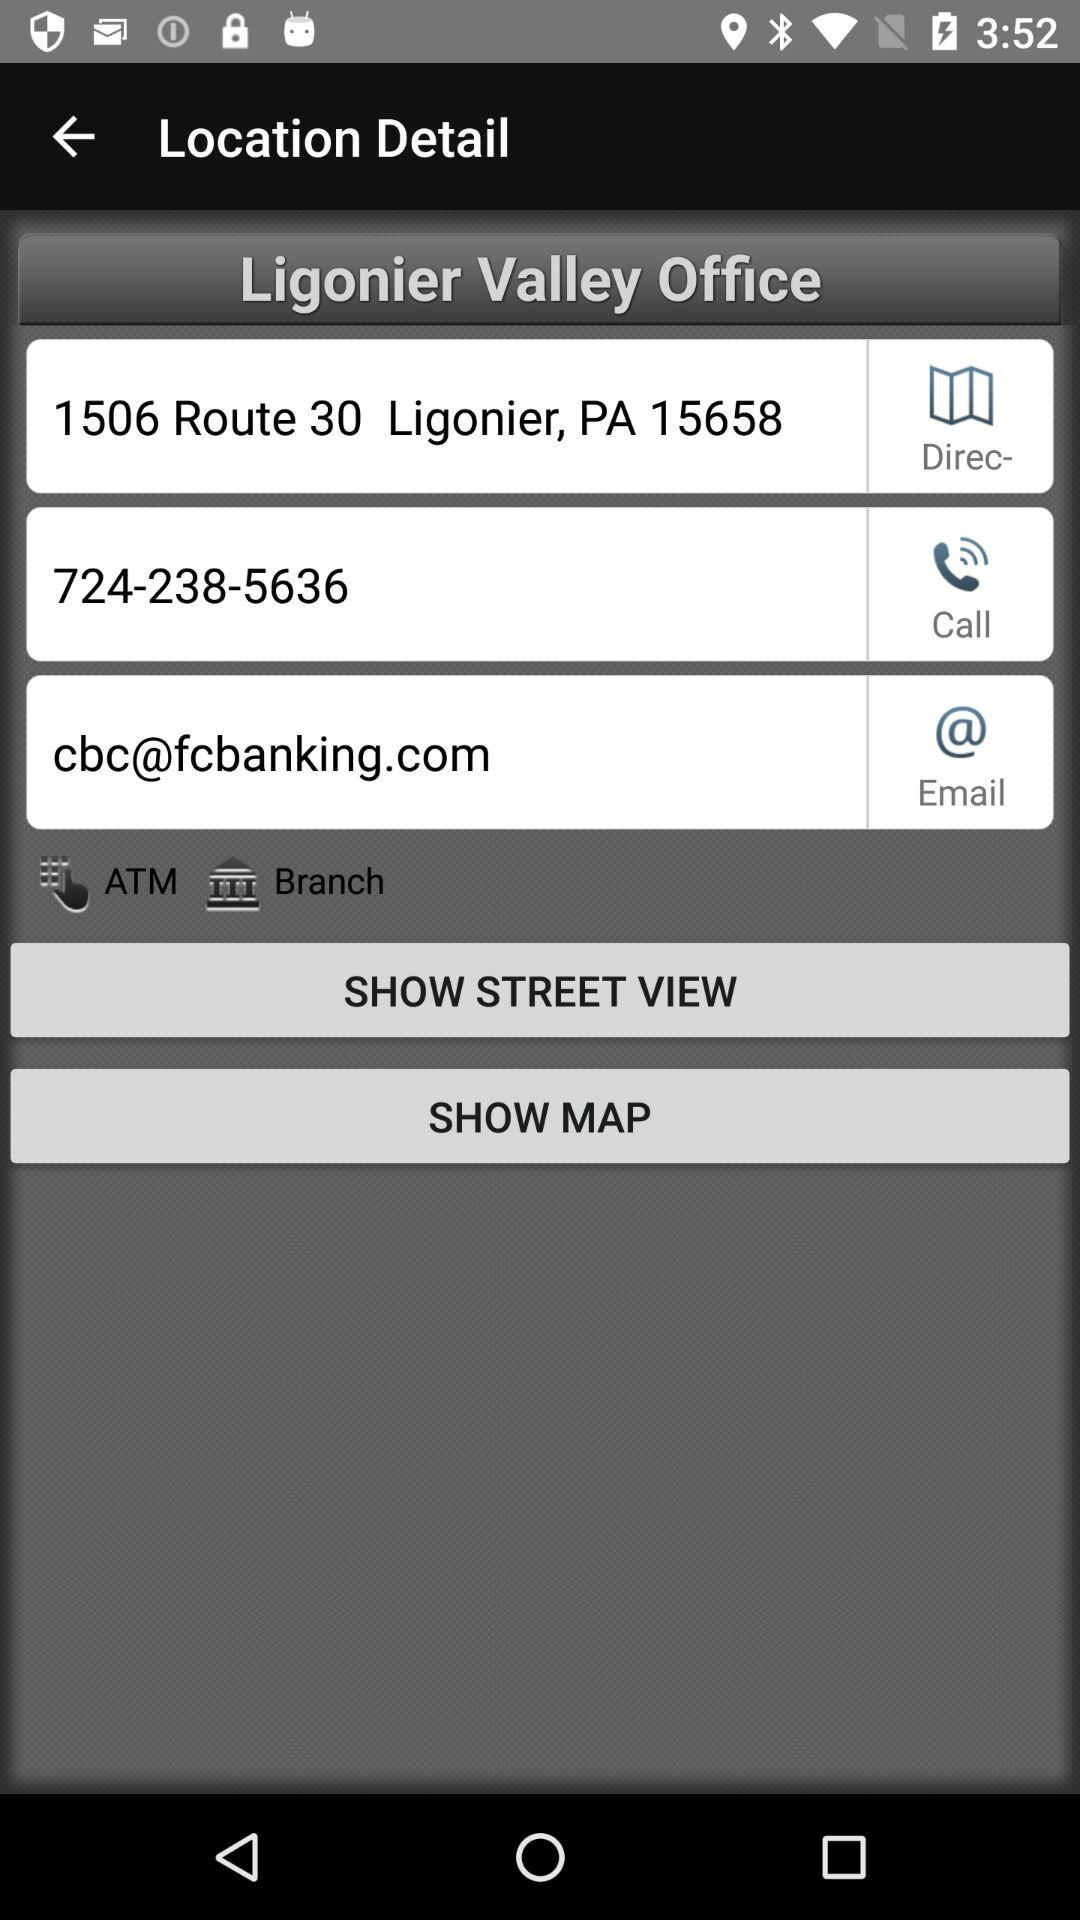What is the address given for the Ligonier Valley office? The given address is 1506 Route 30, Ligonier, PA 15658. 